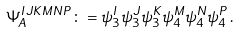<formula> <loc_0><loc_0><loc_500><loc_500>\Psi _ { A } ^ { I J K M N P } \colon = \psi ^ { I } _ { 3 } \psi ^ { J } _ { 3 } \psi ^ { K } _ { 3 } \psi ^ { M } _ { 4 } \psi ^ { N } _ { 4 } \psi ^ { P } _ { 4 } \, .</formula> 